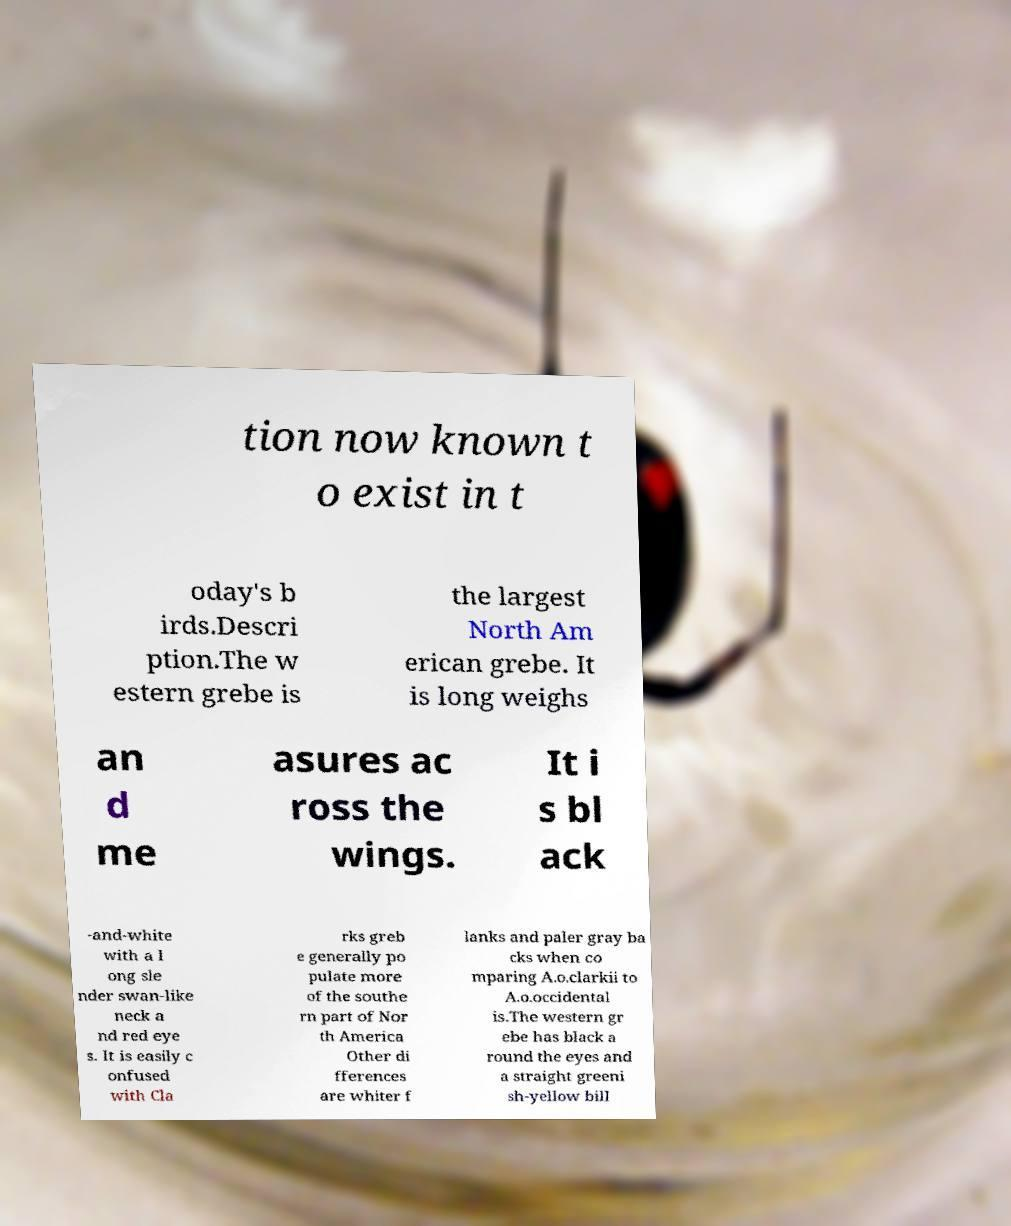Could you assist in decoding the text presented in this image and type it out clearly? tion now known t o exist in t oday's b irds.Descri ption.The w estern grebe is the largest North Am erican grebe. It is long weighs an d me asures ac ross the wings. It i s bl ack -and-white with a l ong sle nder swan-like neck a nd red eye s. It is easily c onfused with Cla rks greb e generally po pulate more of the southe rn part of Nor th America Other di fferences are whiter f lanks and paler gray ba cks when co mparing A.o.clarkii to A.o.occidental is.The western gr ebe has black a round the eyes and a straight greeni sh-yellow bill 